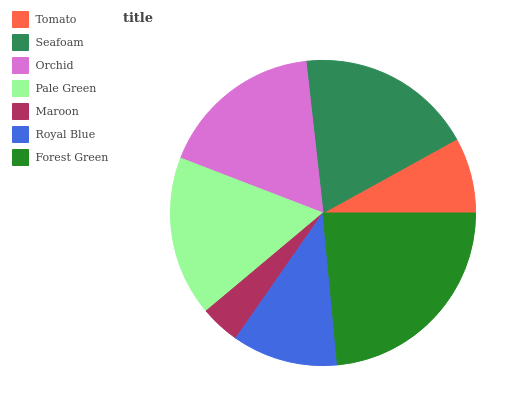Is Maroon the minimum?
Answer yes or no. Yes. Is Forest Green the maximum?
Answer yes or no. Yes. Is Seafoam the minimum?
Answer yes or no. No. Is Seafoam the maximum?
Answer yes or no. No. Is Seafoam greater than Tomato?
Answer yes or no. Yes. Is Tomato less than Seafoam?
Answer yes or no. Yes. Is Tomato greater than Seafoam?
Answer yes or no. No. Is Seafoam less than Tomato?
Answer yes or no. No. Is Pale Green the high median?
Answer yes or no. Yes. Is Pale Green the low median?
Answer yes or no. Yes. Is Orchid the high median?
Answer yes or no. No. Is Orchid the low median?
Answer yes or no. No. 